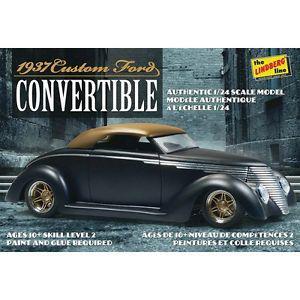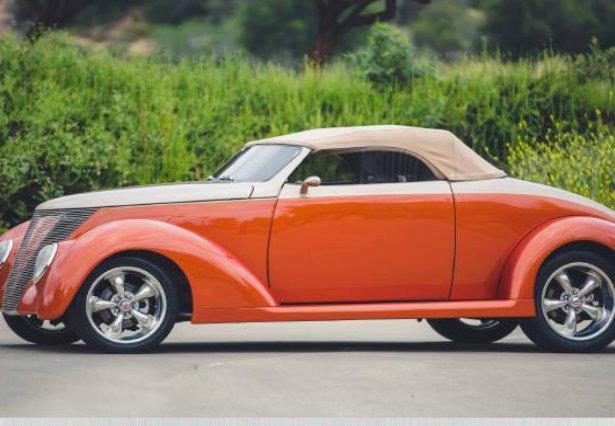The first image is the image on the left, the second image is the image on the right. Examine the images to the left and right. Is the description "The foreground cars in the left and right images face the same direction, and the righthand car is parked on a paved strip surrounded by grass and has a royal blue hood with a silver body." accurate? Answer yes or no. No. The first image is the image on the left, the second image is the image on the right. For the images shown, is this caption "One car has a tan roof" true? Answer yes or no. Yes. 